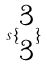<formula> <loc_0><loc_0><loc_500><loc_500>s \{ \begin{matrix} 3 \\ 3 \end{matrix} \}</formula> 